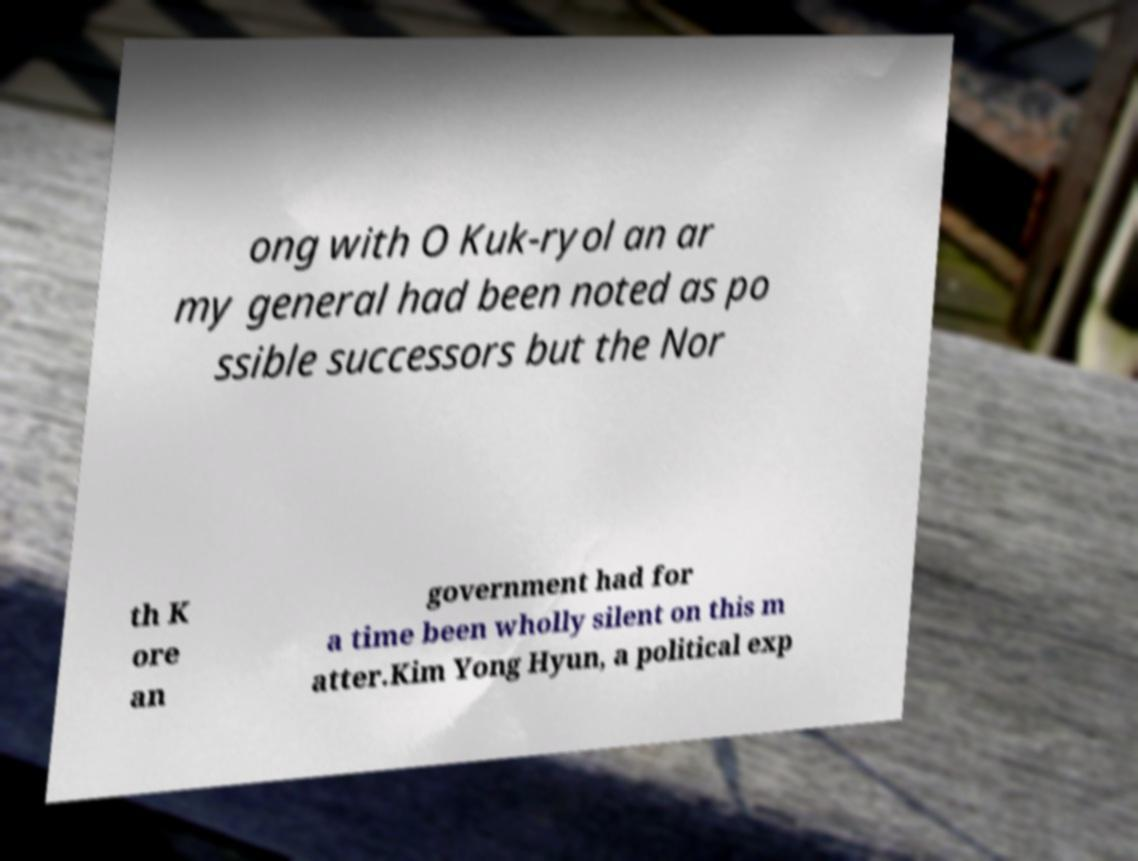What messages or text are displayed in this image? I need them in a readable, typed format. ong with O Kuk-ryol an ar my general had been noted as po ssible successors but the Nor th K ore an government had for a time been wholly silent on this m atter.Kim Yong Hyun, a political exp 